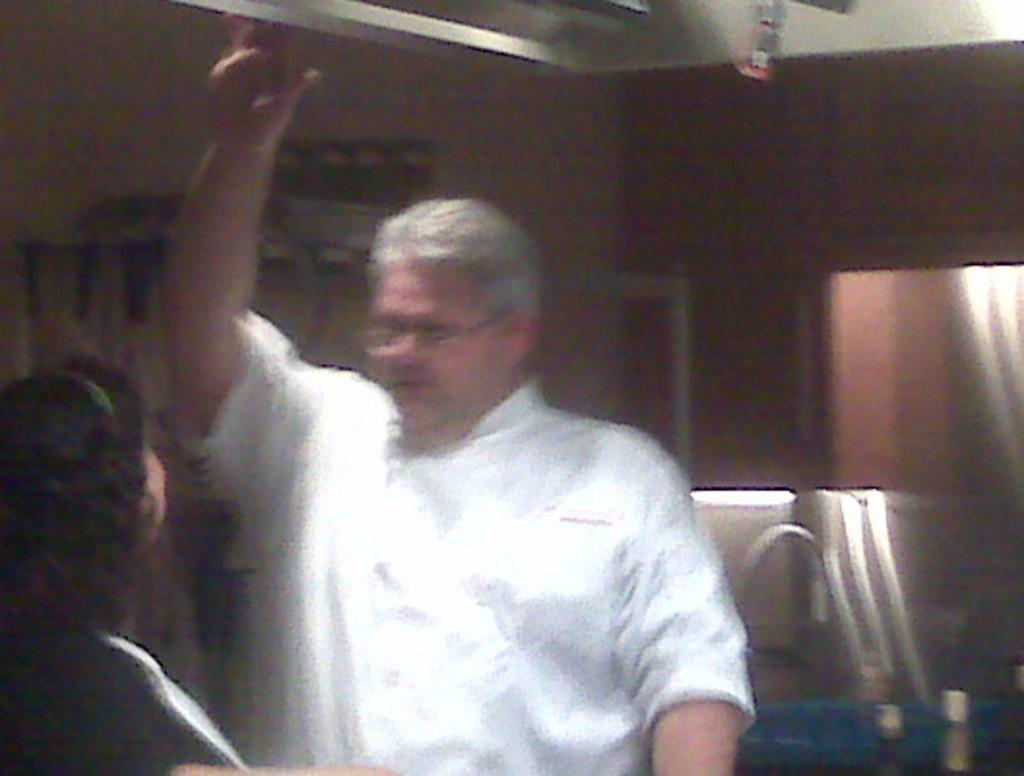Who are the people in the image? There is a man and a woman in the image. Can you describe the relationship between the man and the woman? The facts provided do not give any information about the relationship between the man and the woman. What are the man and the woman doing in the image? The facts provided do not give any information about what the man and the woman are doing in the image. What type of cactus can be seen in the background of the image? There is no cactus present in the image. Can you describe the church that is visible in the image? There is no church present in the image. 